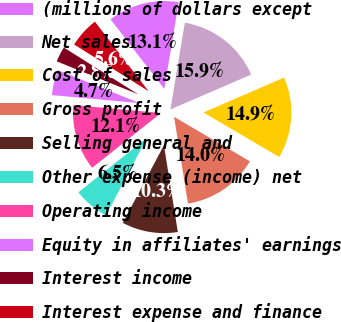Convert chart. <chart><loc_0><loc_0><loc_500><loc_500><pie_chart><fcel>(millions of dollars except<fcel>Net sales<fcel>Cost of sales<fcel>Gross profit<fcel>Selling general and<fcel>Other expense (income) net<fcel>Operating income<fcel>Equity in affiliates' earnings<fcel>Interest income<fcel>Interest expense and finance<nl><fcel>13.08%<fcel>15.89%<fcel>14.95%<fcel>14.02%<fcel>10.28%<fcel>6.54%<fcel>12.15%<fcel>4.67%<fcel>2.81%<fcel>5.61%<nl></chart> 